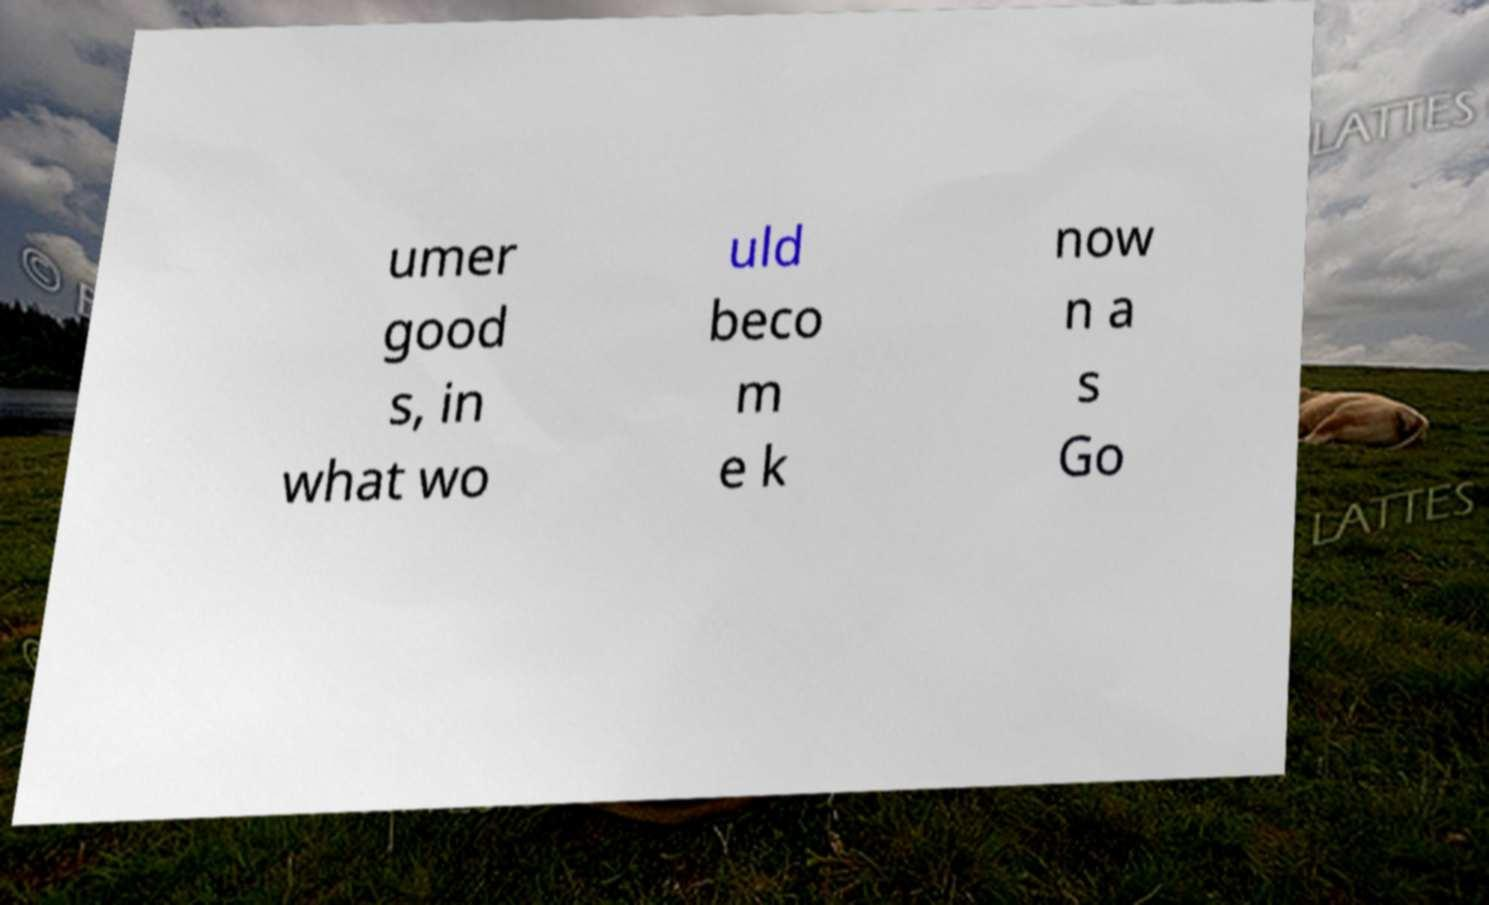Please read and relay the text visible in this image. What does it say? umer good s, in what wo uld beco m e k now n a s Go 